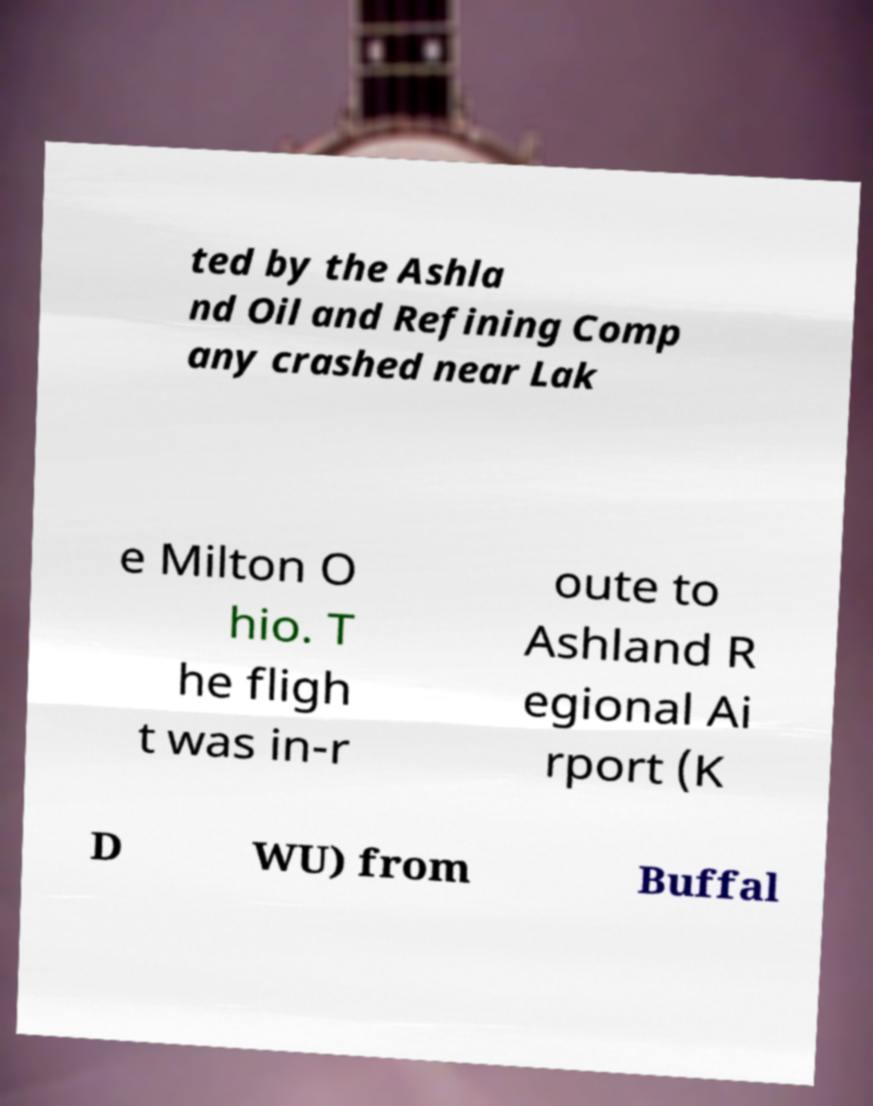I need the written content from this picture converted into text. Can you do that? ted by the Ashla nd Oil and Refining Comp any crashed near Lak e Milton O hio. T he fligh t was in-r oute to Ashland R egional Ai rport (K D WU) from Buffal 